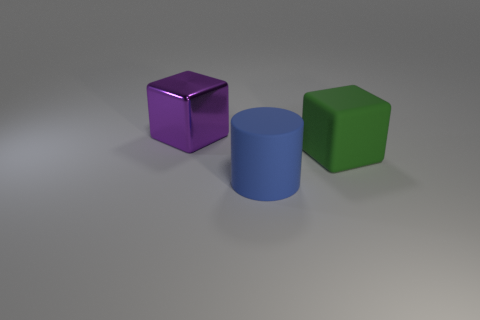What number of purple metal blocks are the same size as the green thing?
Offer a terse response. 1. What number of large blue matte cylinders are on the left side of the object that is to the right of the large rubber object that is in front of the large green matte thing?
Your response must be concise. 1. How many big objects are left of the green object and behind the large blue cylinder?
Your answer should be very brief. 1. Is there anything else that has the same color as the matte cylinder?
Give a very brief answer. No. What number of matte things are either blue things or yellow blocks?
Your response must be concise. 1. The cube that is on the left side of the big object in front of the large block that is in front of the purple shiny object is made of what material?
Your answer should be compact. Metal. There is a big thing that is to the left of the rubber object that is in front of the green rubber block; what is its material?
Provide a short and direct response. Metal. Does the matte object that is in front of the green rubber object have the same size as the block that is on the right side of the large purple metal object?
Make the answer very short. Yes. Are there any other things that have the same material as the big purple object?
Your answer should be very brief. No. How many small objects are either gray shiny cylinders or matte things?
Make the answer very short. 0. 